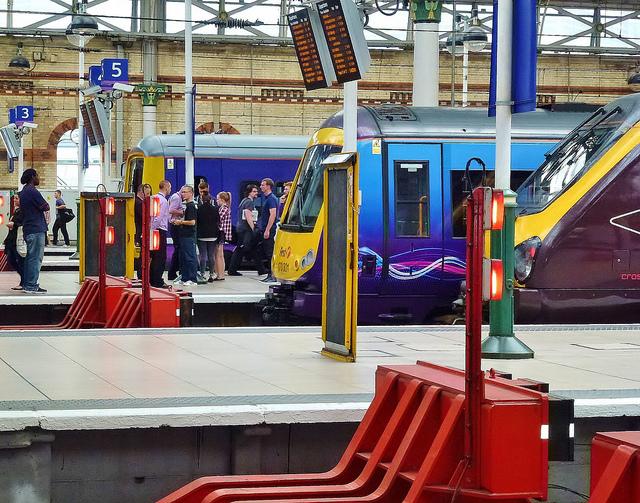What is the furthest visible train platform number?
Keep it brief. 3. What train platform numbers are shown?
Be succinct. 3 and 5. What color is the train?
Quick response, please. Blue. 